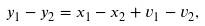<formula> <loc_0><loc_0><loc_500><loc_500>y _ { 1 } - y _ { 2 } = x _ { 1 } - x _ { 2 } + v _ { 1 } - v _ { 2 } ,</formula> 